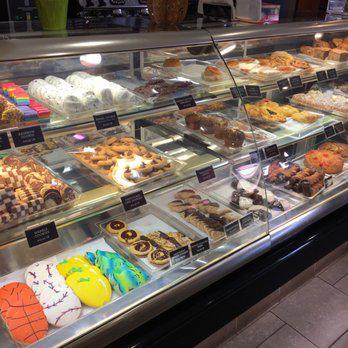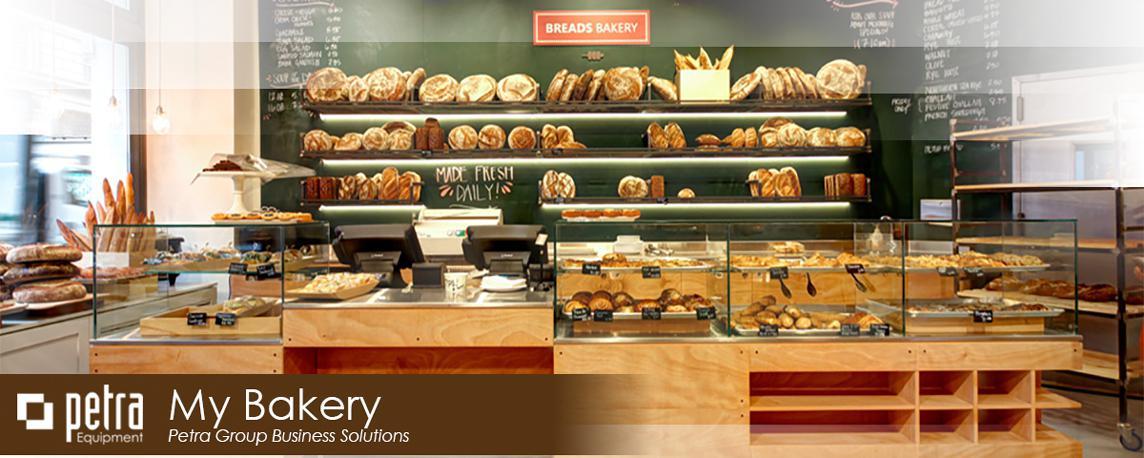The first image is the image on the left, the second image is the image on the right. Given the left and right images, does the statement "The shop door is at least partially visible in the iamge on the right" hold true? Answer yes or no. No. 